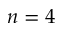<formula> <loc_0><loc_0><loc_500><loc_500>n = 4</formula> 